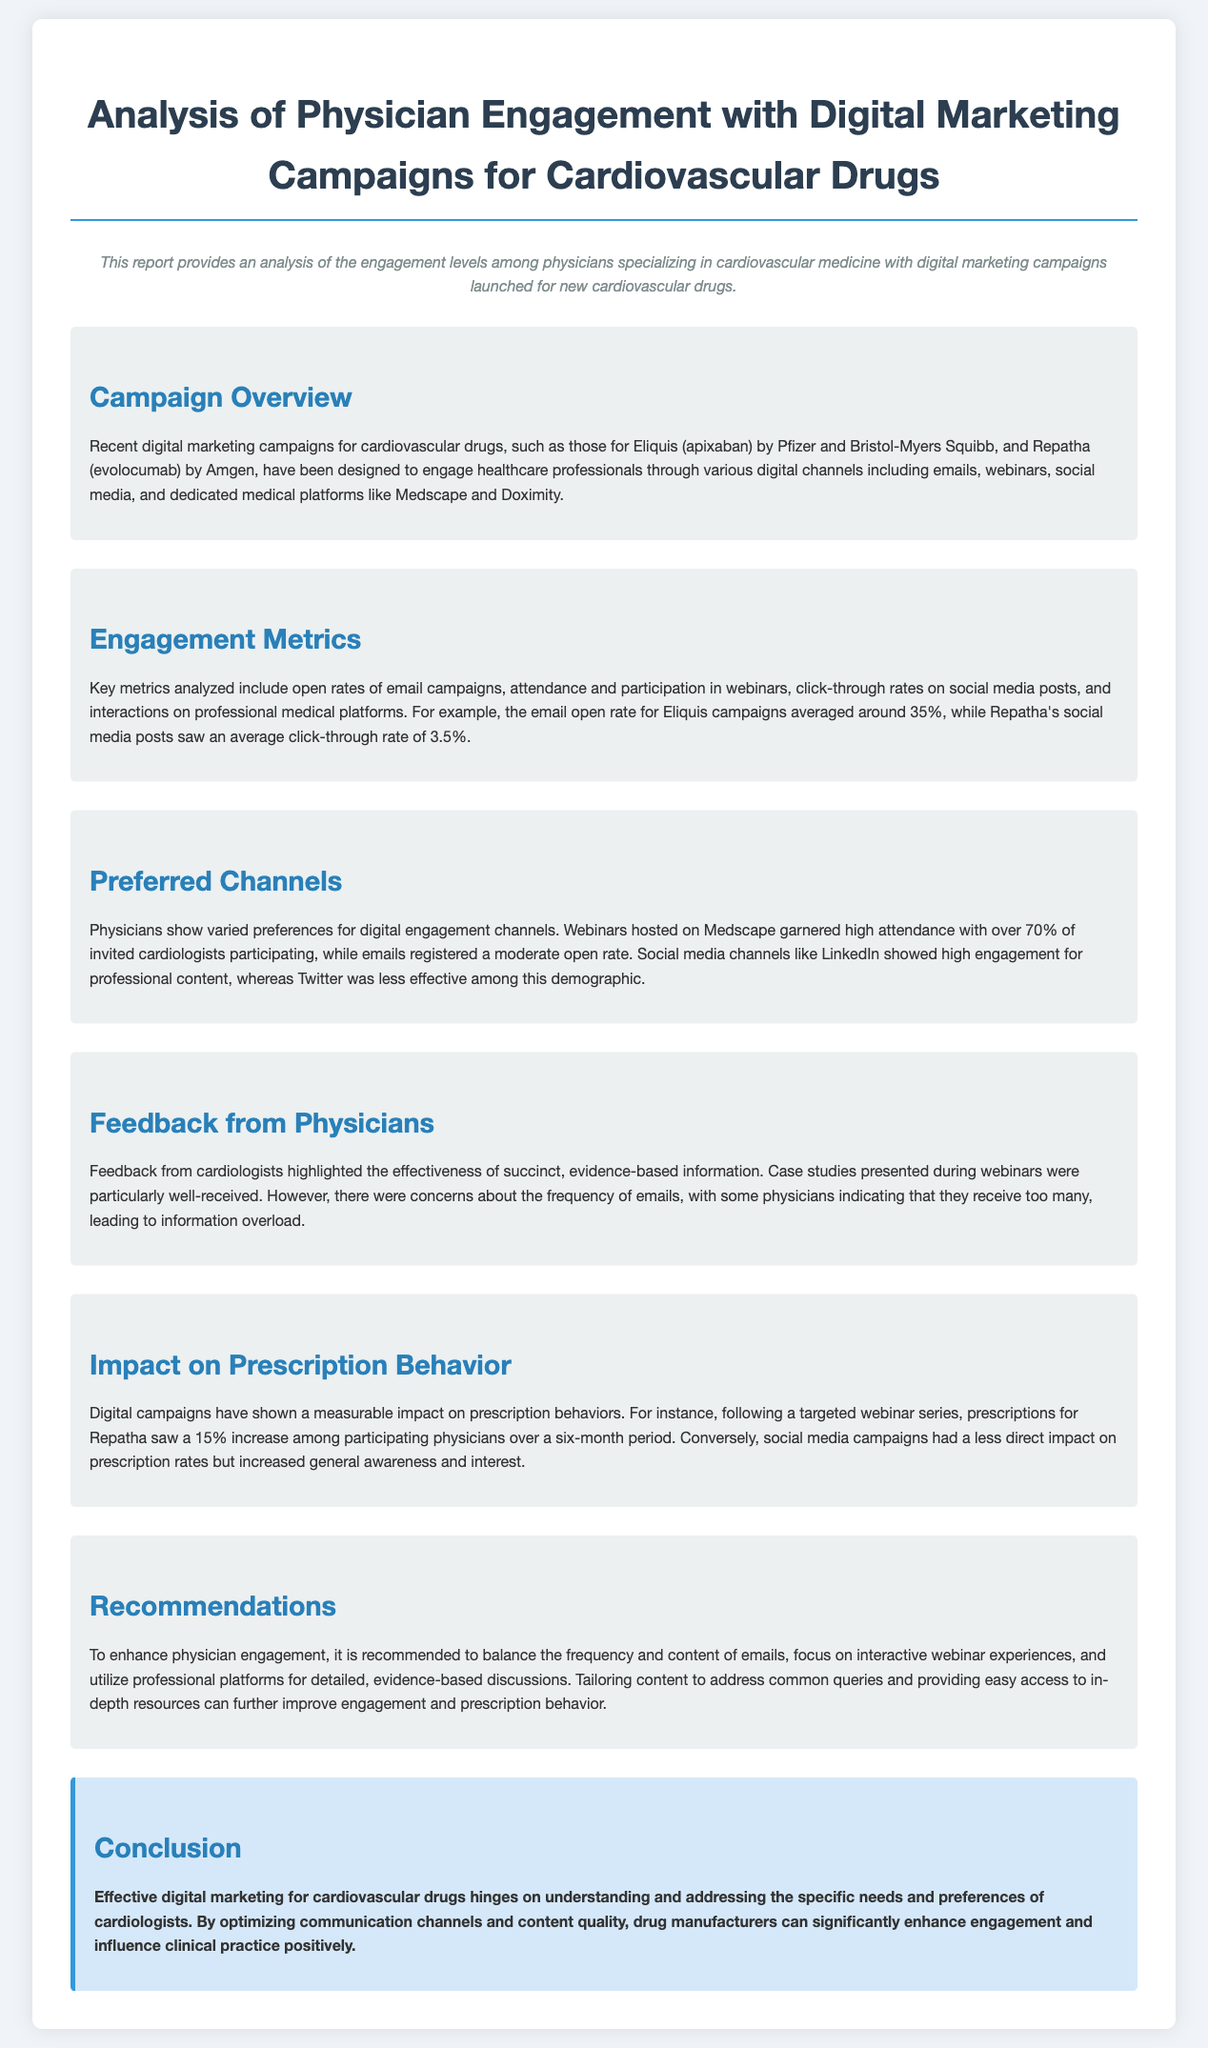What is the average email open rate for Eliquis campaigns? The document states that the email open rate for Eliquis campaigns averaged around 35%.
Answer: 35% What was the click-through rate for Repatha's social media posts? The document mentions that Repatha's social media posts saw an average click-through rate of 3.5%.
Answer: 3.5% Which digital channel had the highest participation rate? The section on preferred channels indicates that webinars hosted on Medscape garnered high attendance.
Answer: Medscape What percentage increase in prescriptions for Repatha was observed after the webinar series? The document reports a 15% increase in prescriptions for Repatha among participating physicians.
Answer: 15% What did cardiologists find effective in their feedback? Cardiologists highlighted the effectiveness of succinct, evidence-based information in feedback.
Answer: Succinct, evidence-based information What frequency-related concern did physicians express? Some physicians indicated that they receive too many emails, leading to information overload.
Answer: Too many emails What type of content is recommended for emails to enhance engagement? The recommendations section suggests balancing the frequency and content of emails.
Answer: Balance frequency and content What impact did digital campaigns have on prescription behavior? The document states that digital campaigns showed a measurable impact on prescription behaviors.
Answer: Measurable impact What is one key recommendation for enhancing physician engagement? Focusing on interactive webinar experiences is a key recommendation mentioned.
Answer: Interactive webinars 